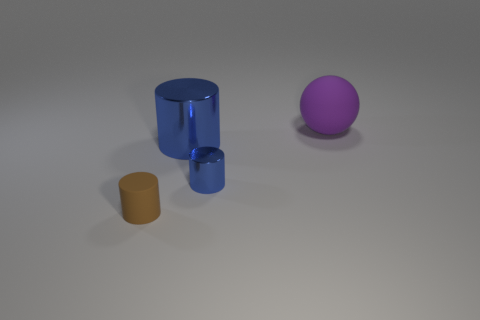Are there fewer rubber objects than large rubber spheres?
Offer a very short reply. No. Are any tiny brown matte cylinders visible?
Offer a very short reply. Yes. What number of other things are the same size as the purple matte thing?
Ensure brevity in your answer.  1. Is the brown thing made of the same material as the big object that is in front of the large matte sphere?
Provide a succinct answer. No. Are there the same number of tiny blue cylinders behind the large purple ball and big objects that are behind the large blue cylinder?
Your answer should be compact. No. What material is the small blue object?
Make the answer very short. Metal. What is the color of the metallic thing that is the same size as the rubber cylinder?
Provide a short and direct response. Blue. There is a large ball behind the small brown cylinder; is there a tiny rubber object left of it?
Your response must be concise. Yes. How many cylinders are either large purple matte objects or big objects?
Your answer should be very brief. 1. There is a cylinder on the right side of the cylinder behind the tiny cylinder right of the tiny brown object; how big is it?
Your answer should be very brief. Small. 